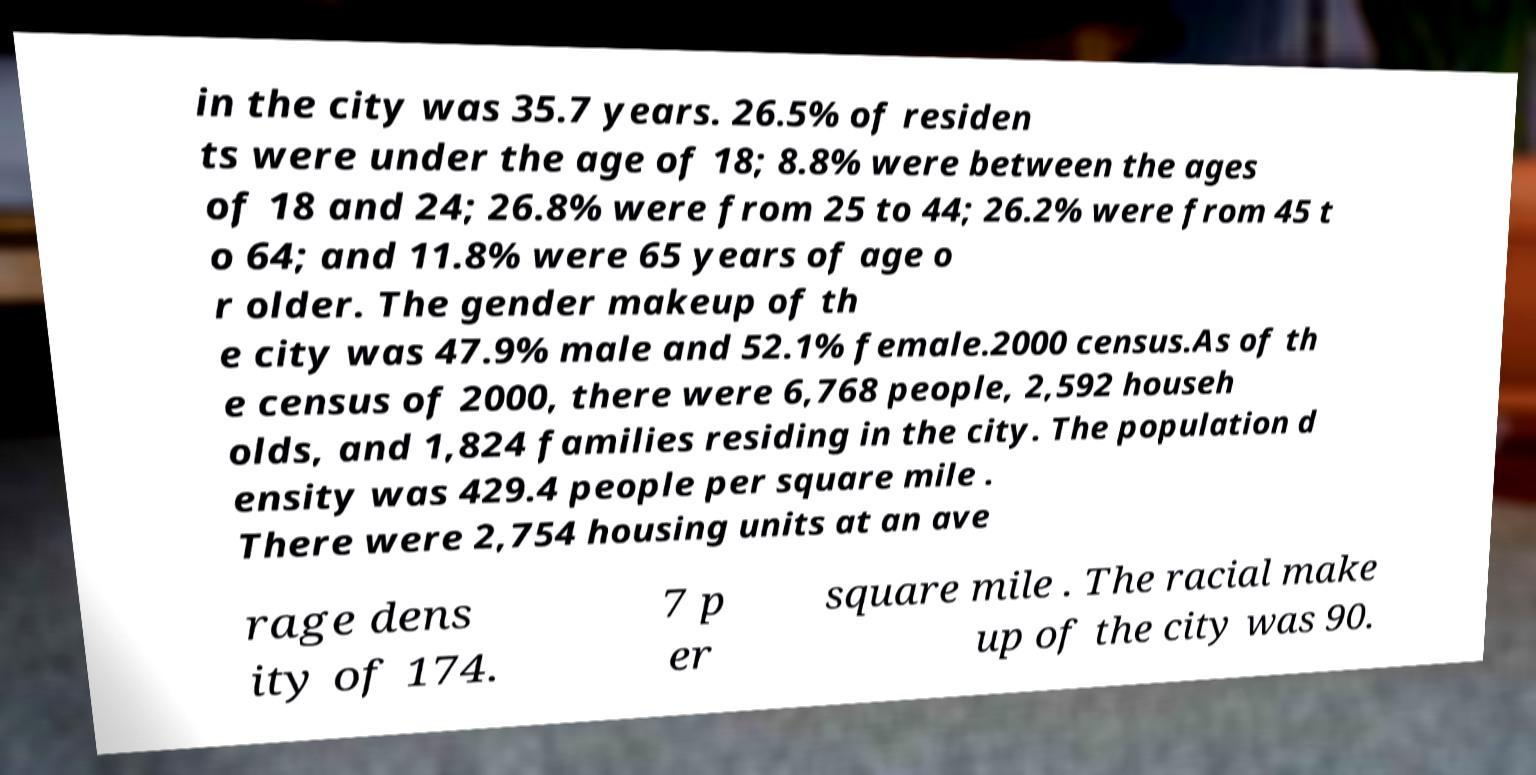Can you read and provide the text displayed in the image?This photo seems to have some interesting text. Can you extract and type it out for me? in the city was 35.7 years. 26.5% of residen ts were under the age of 18; 8.8% were between the ages of 18 and 24; 26.8% were from 25 to 44; 26.2% were from 45 t o 64; and 11.8% were 65 years of age o r older. The gender makeup of th e city was 47.9% male and 52.1% female.2000 census.As of th e census of 2000, there were 6,768 people, 2,592 househ olds, and 1,824 families residing in the city. The population d ensity was 429.4 people per square mile . There were 2,754 housing units at an ave rage dens ity of 174. 7 p er square mile . The racial make up of the city was 90. 